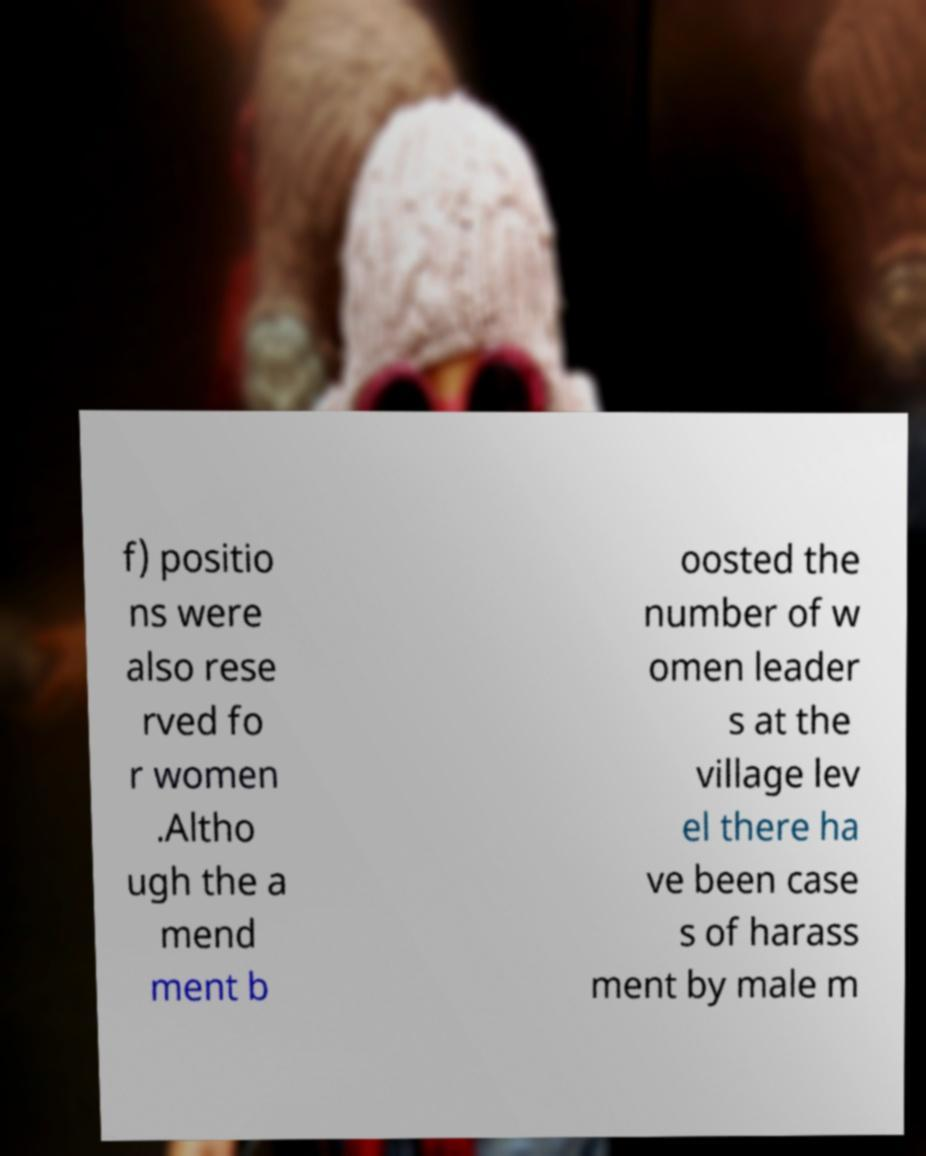Can you accurately transcribe the text from the provided image for me? f) positio ns were also rese rved fo r women .Altho ugh the a mend ment b oosted the number of w omen leader s at the village lev el there ha ve been case s of harass ment by male m 